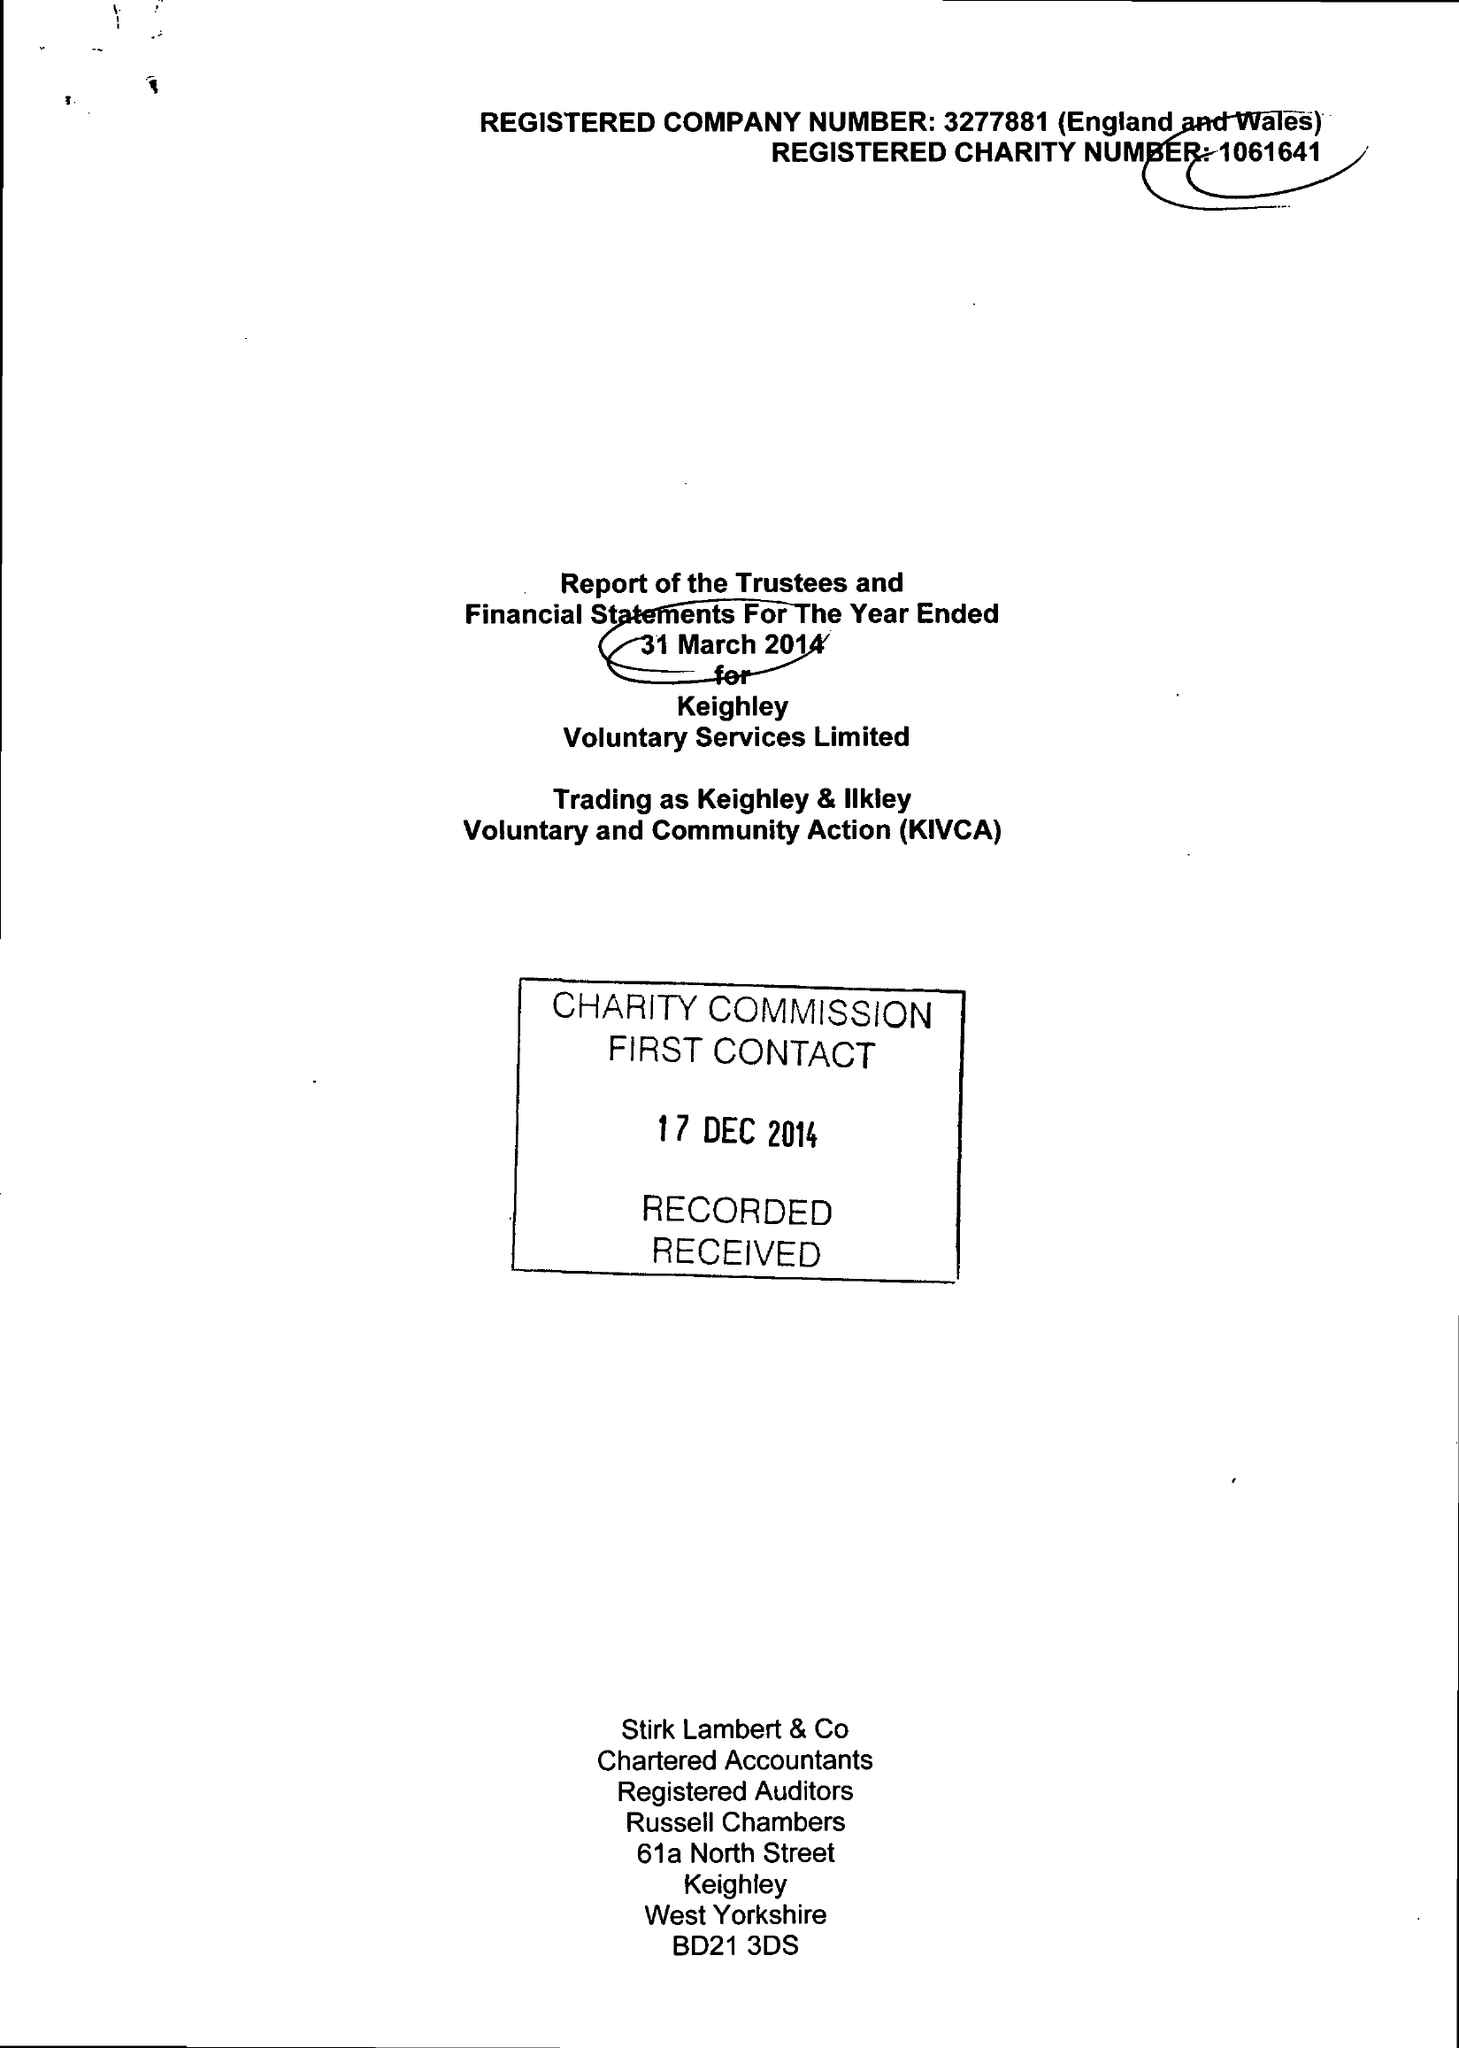What is the value for the address__street_line?
Answer the question using a single word or phrase. ALICE STREET 